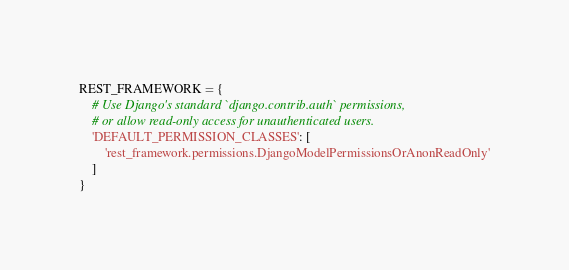Convert code to text. <code><loc_0><loc_0><loc_500><loc_500><_Python_>REST_FRAMEWORK = {
    # Use Django's standard `django.contrib.auth` permissions,
    # or allow read-only access for unauthenticated users.
    'DEFAULT_PERMISSION_CLASSES': [
        'rest_framework.permissions.DjangoModelPermissionsOrAnonReadOnly'
    ]
}</code> 